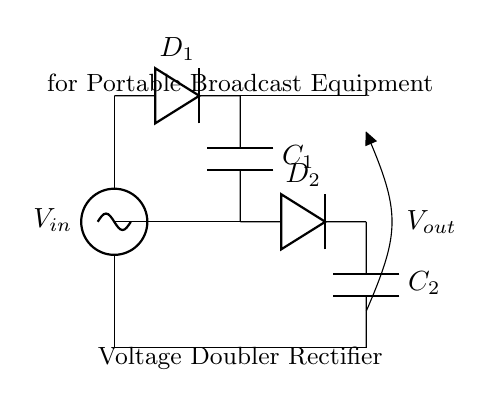What is the input voltage in this circuit? The input voltage is represented by the symbol V_in at the top of the circuit diagram.
Answer: V_in What components are used in this voltage doubler rectifier circuit? The circuit contains capacitors, represented by C_1 and C_2, and diodes, represented by D_1 and D_2.
Answer: Capacitors and Diodes How many diodes are in this circuit? The circuit shows two diodes, labeled D_1 and D_2, connecting various points in the circuit.
Answer: Two What is the purpose of the capacitors in this circuit? The capacitors, C_1 and C_2, store charge and help smooth out the output voltage, functioning as energy storage elements during the rectification process.
Answer: Energy storage What is the output voltage relative to the input voltage? This is a voltage doubler rectifier, meaning the output voltage (V_out) will ideally be approximately double the input voltage (V_in) after rectification.
Answer: Approximately 2 * V_in Which direction do the diodes conduct current in this circuit? D_1 conducts current when the input voltage is positive, allowing current to pass to C_1, while D_2 conducts during the negative half cycle, allowing charging of C_2, ensuring current flows in the intended direction toward the output.
Answer: Forward for D_1; reverse for D_2 